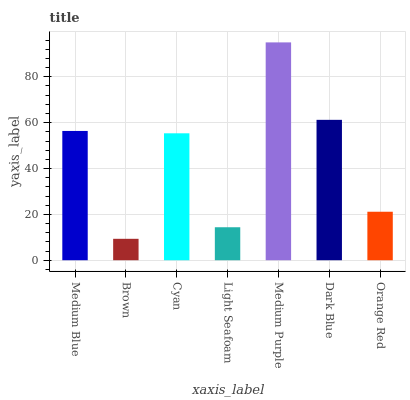Is Brown the minimum?
Answer yes or no. Yes. Is Medium Purple the maximum?
Answer yes or no. Yes. Is Cyan the minimum?
Answer yes or no. No. Is Cyan the maximum?
Answer yes or no. No. Is Cyan greater than Brown?
Answer yes or no. Yes. Is Brown less than Cyan?
Answer yes or no. Yes. Is Brown greater than Cyan?
Answer yes or no. No. Is Cyan less than Brown?
Answer yes or no. No. Is Cyan the high median?
Answer yes or no. Yes. Is Cyan the low median?
Answer yes or no. Yes. Is Orange Red the high median?
Answer yes or no. No. Is Brown the low median?
Answer yes or no. No. 